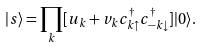<formula> <loc_0><loc_0><loc_500><loc_500>| s \rangle = \prod _ { k } [ u _ { k } + v _ { k } c ^ { \dag } _ { k \uparrow } c ^ { \dag } _ { - k \downarrow } ] | 0 \rangle .</formula> 